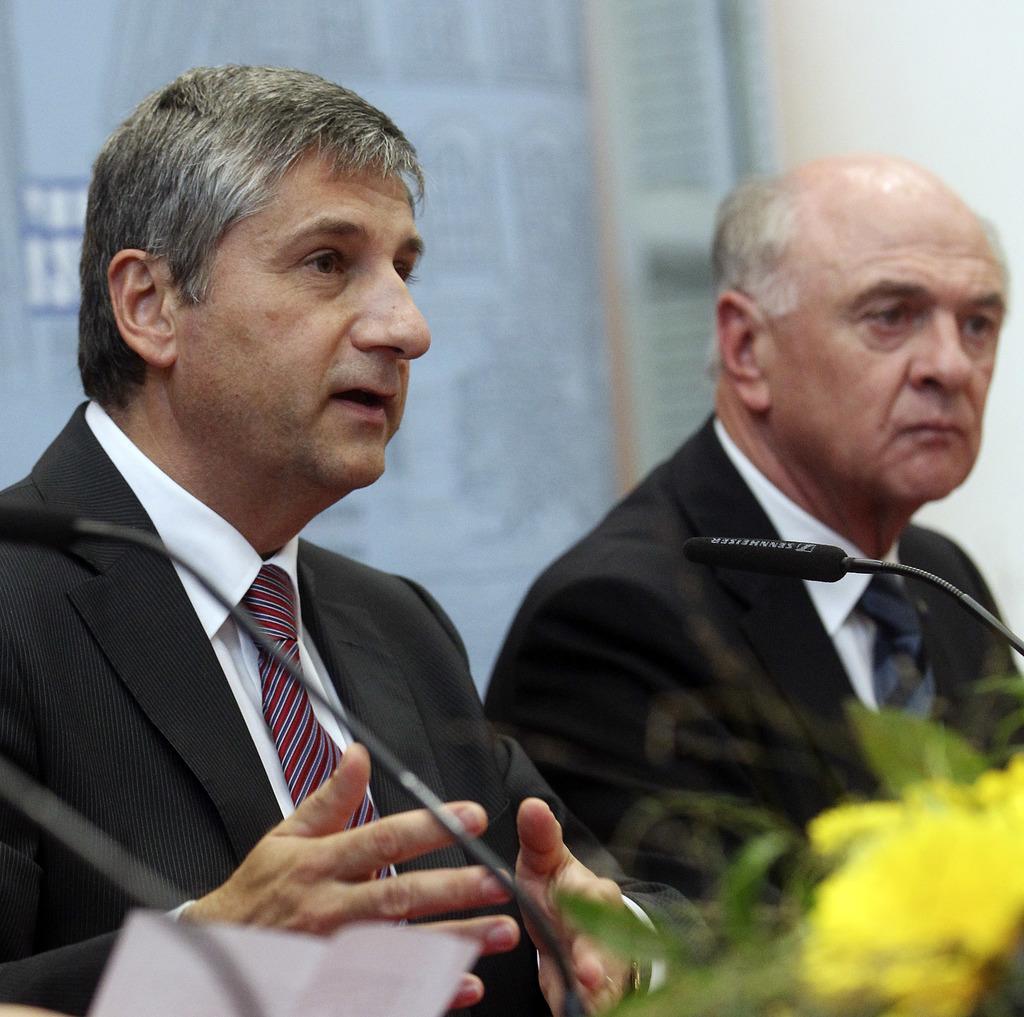Can you describe this image briefly? In this image we can see two men. We can also see a paper, some mics with stand and a plant with a flower in front of them. On the backside we can see a board on a wall. 